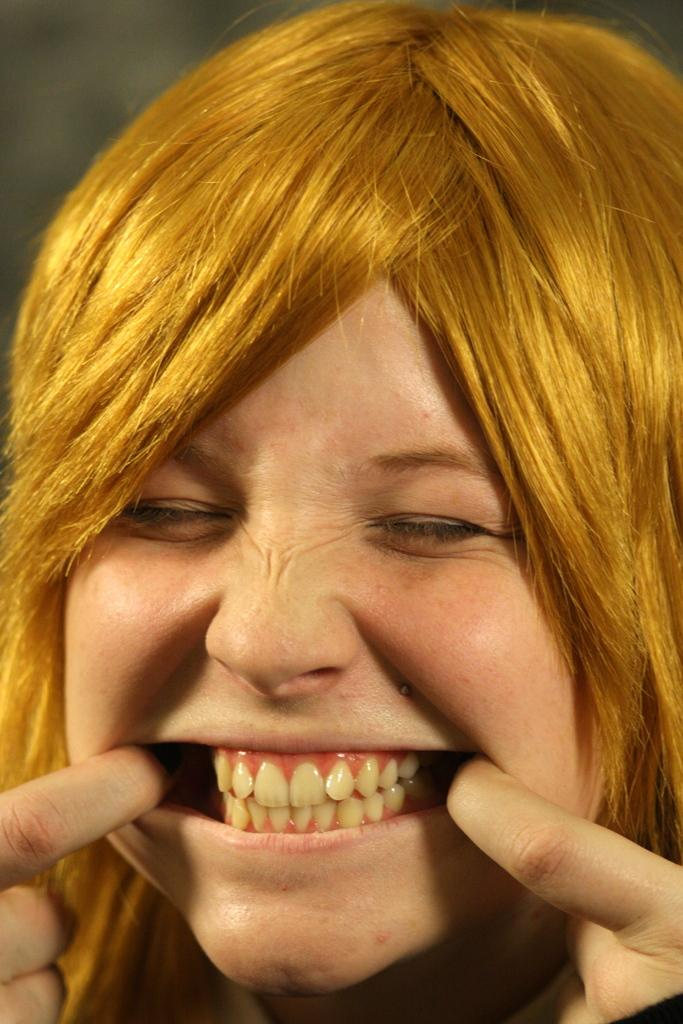Who is the main subject in the image? There is a lady in the center of the image. What is the lady doing in the image? The lady is opening her mouth with her fingers. Can you describe the lady's teeth in the image? The lady's teeth are visible in the image. How would you describe the background of the image? The background of the image is blurry. What type of crib can be seen in the background of the image? There is no crib present in the image; the background is blurry. 